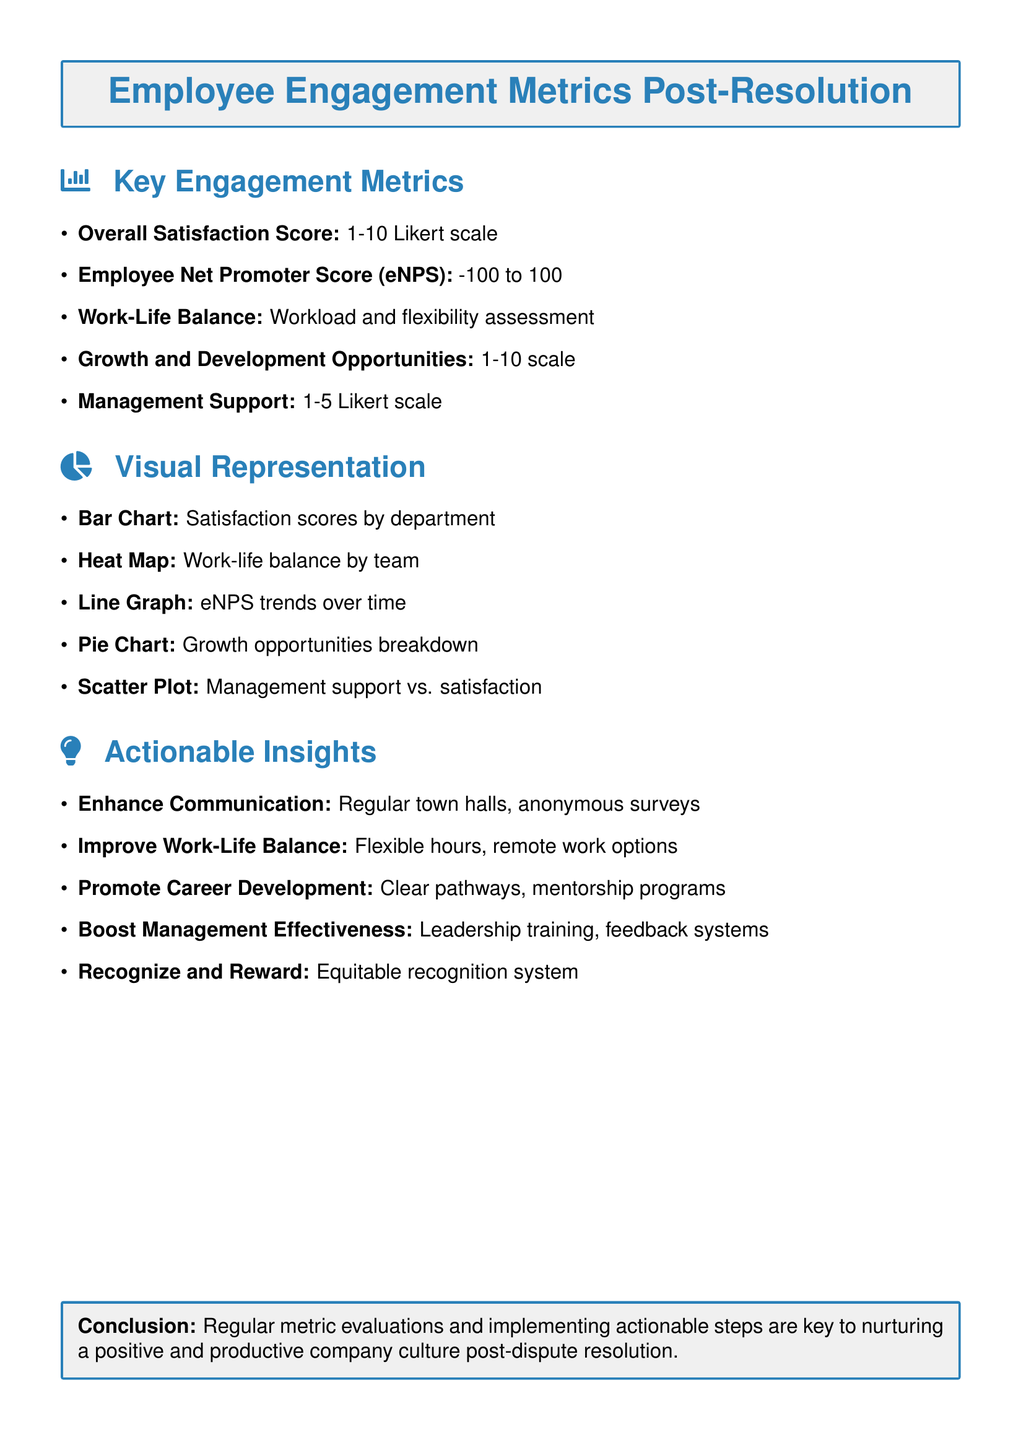what is the Overall Satisfaction Score scale? The Overall Satisfaction Score is measured on a 1-10 Likert scale.
Answer: 1-10 Likert scale what metric is used to assess work-life balance? Work-life balance is assessed through workload and flexibility assessment.
Answer: Workload and flexibility assessment what visual representation shows satisfaction scores by department? A Bar Chart visual representation displays satisfaction scores by department.
Answer: Bar Chart which actionable insight focuses on enhancing communication? The actionable insight that focuses on enhancing communication is regular town halls and anonymous surveys.
Answer: Enhance Communication what is the range of the Employee Net Promoter Score (eNPS)? The range of the eNPS is from -100 to 100.
Answer: -100 to 100 what does the heat map represent? The heat map represents work-life balance by team.
Answer: Work-life balance by team how can career development opportunities be promoted according to actionable insights? Career development can be promoted through clear pathways and mentorship programs.
Answer: Clear pathways, mentorship programs what type of training is recommended to boost management effectiveness? Leadership training is recommended to boost management effectiveness.
Answer: Leadership training 